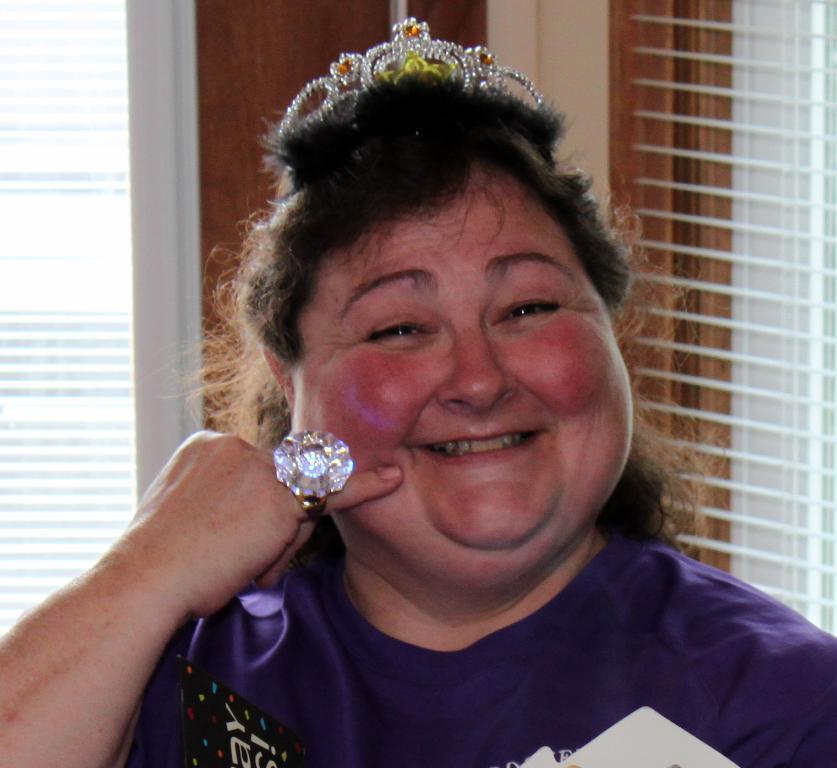Can you describe this image briefly? In this image, we can see a woman with crown and finger ring. She is smiling. In the background, we can see wooden object, window shades and glass objects. 